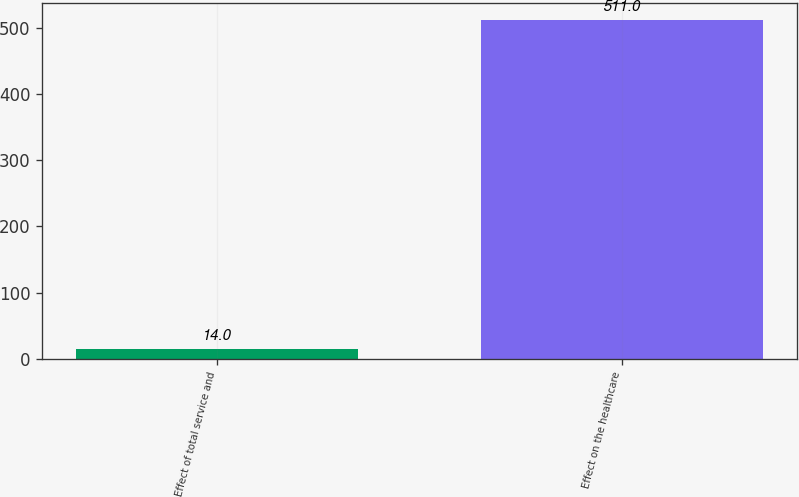<chart> <loc_0><loc_0><loc_500><loc_500><bar_chart><fcel>Effect of total service and<fcel>Effect on the healthcare<nl><fcel>14<fcel>511<nl></chart> 